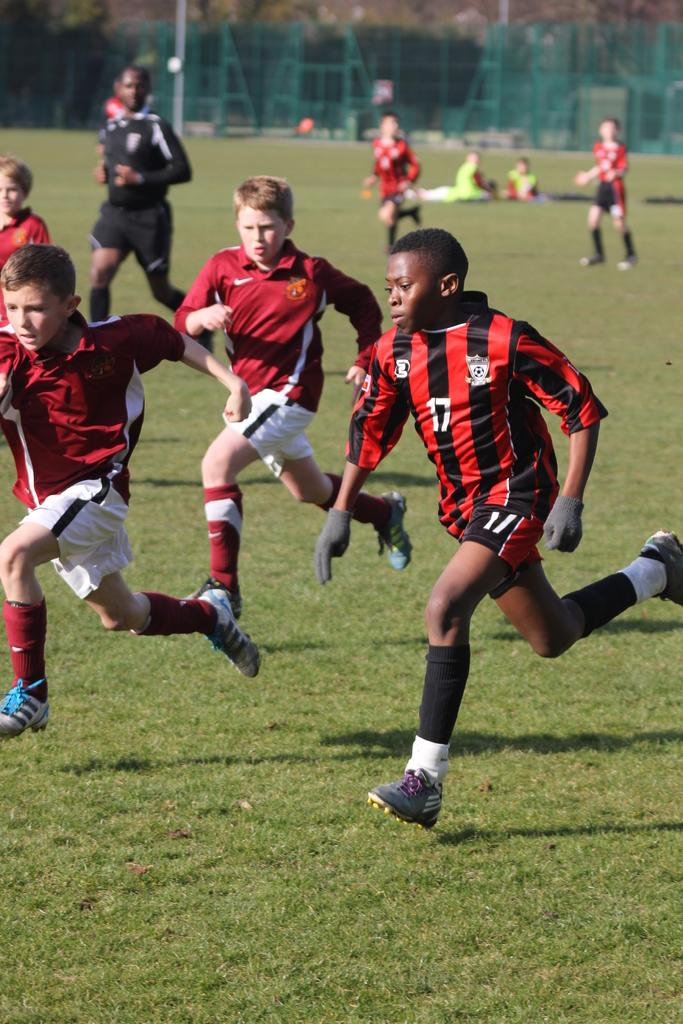<image>
Give a short and clear explanation of the subsequent image. soccer players with one of them wearing the number 17 